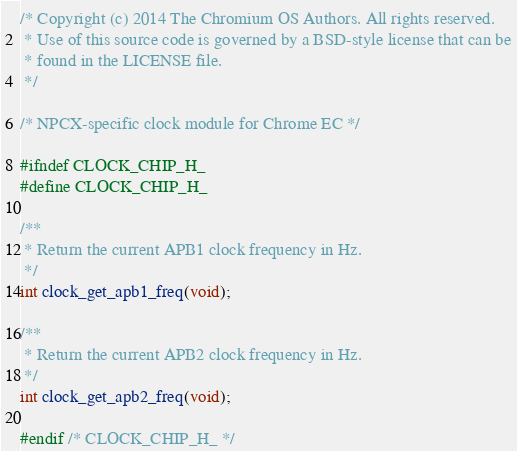Convert code to text. <code><loc_0><loc_0><loc_500><loc_500><_C_>/* Copyright (c) 2014 The Chromium OS Authors. All rights reserved.
 * Use of this source code is governed by a BSD-style license that can be
 * found in the LICENSE file.
 */

/* NPCX-specific clock module for Chrome EC */

#ifndef CLOCK_CHIP_H_
#define CLOCK_CHIP_H_

/**
 * Return the current APB1 clock frequency in Hz.
 */
int clock_get_apb1_freq(void);

/**
 * Return the current APB2 clock frequency in Hz.
 */
int clock_get_apb2_freq(void);

#endif /* CLOCK_CHIP_H_ */
</code> 